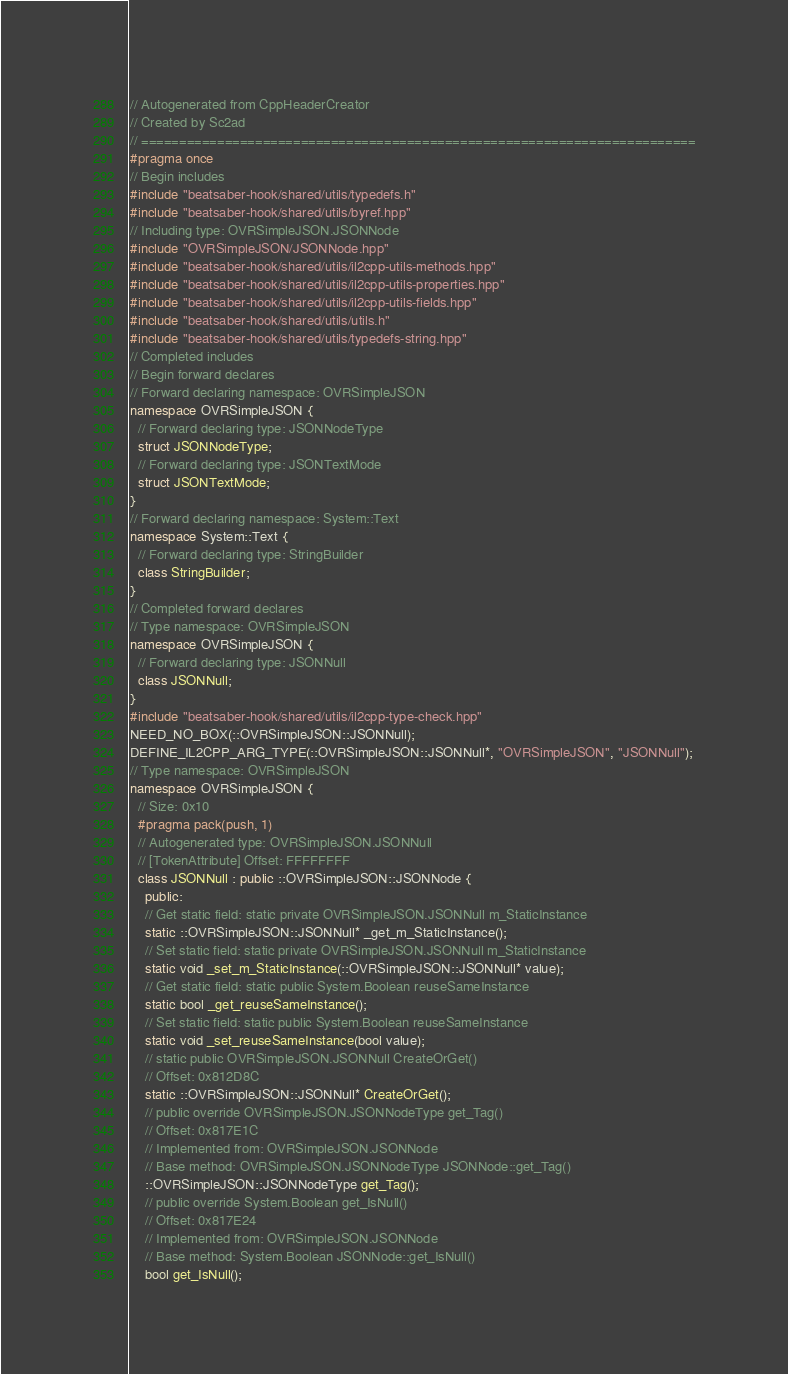Convert code to text. <code><loc_0><loc_0><loc_500><loc_500><_C++_>// Autogenerated from CppHeaderCreator
// Created by Sc2ad
// =========================================================================
#pragma once
// Begin includes
#include "beatsaber-hook/shared/utils/typedefs.h"
#include "beatsaber-hook/shared/utils/byref.hpp"
// Including type: OVRSimpleJSON.JSONNode
#include "OVRSimpleJSON/JSONNode.hpp"
#include "beatsaber-hook/shared/utils/il2cpp-utils-methods.hpp"
#include "beatsaber-hook/shared/utils/il2cpp-utils-properties.hpp"
#include "beatsaber-hook/shared/utils/il2cpp-utils-fields.hpp"
#include "beatsaber-hook/shared/utils/utils.h"
#include "beatsaber-hook/shared/utils/typedefs-string.hpp"
// Completed includes
// Begin forward declares
// Forward declaring namespace: OVRSimpleJSON
namespace OVRSimpleJSON {
  // Forward declaring type: JSONNodeType
  struct JSONNodeType;
  // Forward declaring type: JSONTextMode
  struct JSONTextMode;
}
// Forward declaring namespace: System::Text
namespace System::Text {
  // Forward declaring type: StringBuilder
  class StringBuilder;
}
// Completed forward declares
// Type namespace: OVRSimpleJSON
namespace OVRSimpleJSON {
  // Forward declaring type: JSONNull
  class JSONNull;
}
#include "beatsaber-hook/shared/utils/il2cpp-type-check.hpp"
NEED_NO_BOX(::OVRSimpleJSON::JSONNull);
DEFINE_IL2CPP_ARG_TYPE(::OVRSimpleJSON::JSONNull*, "OVRSimpleJSON", "JSONNull");
// Type namespace: OVRSimpleJSON
namespace OVRSimpleJSON {
  // Size: 0x10
  #pragma pack(push, 1)
  // Autogenerated type: OVRSimpleJSON.JSONNull
  // [TokenAttribute] Offset: FFFFFFFF
  class JSONNull : public ::OVRSimpleJSON::JSONNode {
    public:
    // Get static field: static private OVRSimpleJSON.JSONNull m_StaticInstance
    static ::OVRSimpleJSON::JSONNull* _get_m_StaticInstance();
    // Set static field: static private OVRSimpleJSON.JSONNull m_StaticInstance
    static void _set_m_StaticInstance(::OVRSimpleJSON::JSONNull* value);
    // Get static field: static public System.Boolean reuseSameInstance
    static bool _get_reuseSameInstance();
    // Set static field: static public System.Boolean reuseSameInstance
    static void _set_reuseSameInstance(bool value);
    // static public OVRSimpleJSON.JSONNull CreateOrGet()
    // Offset: 0x812D8C
    static ::OVRSimpleJSON::JSONNull* CreateOrGet();
    // public override OVRSimpleJSON.JSONNodeType get_Tag()
    // Offset: 0x817E1C
    // Implemented from: OVRSimpleJSON.JSONNode
    // Base method: OVRSimpleJSON.JSONNodeType JSONNode::get_Tag()
    ::OVRSimpleJSON::JSONNodeType get_Tag();
    // public override System.Boolean get_IsNull()
    // Offset: 0x817E24
    // Implemented from: OVRSimpleJSON.JSONNode
    // Base method: System.Boolean JSONNode::get_IsNull()
    bool get_IsNull();</code> 